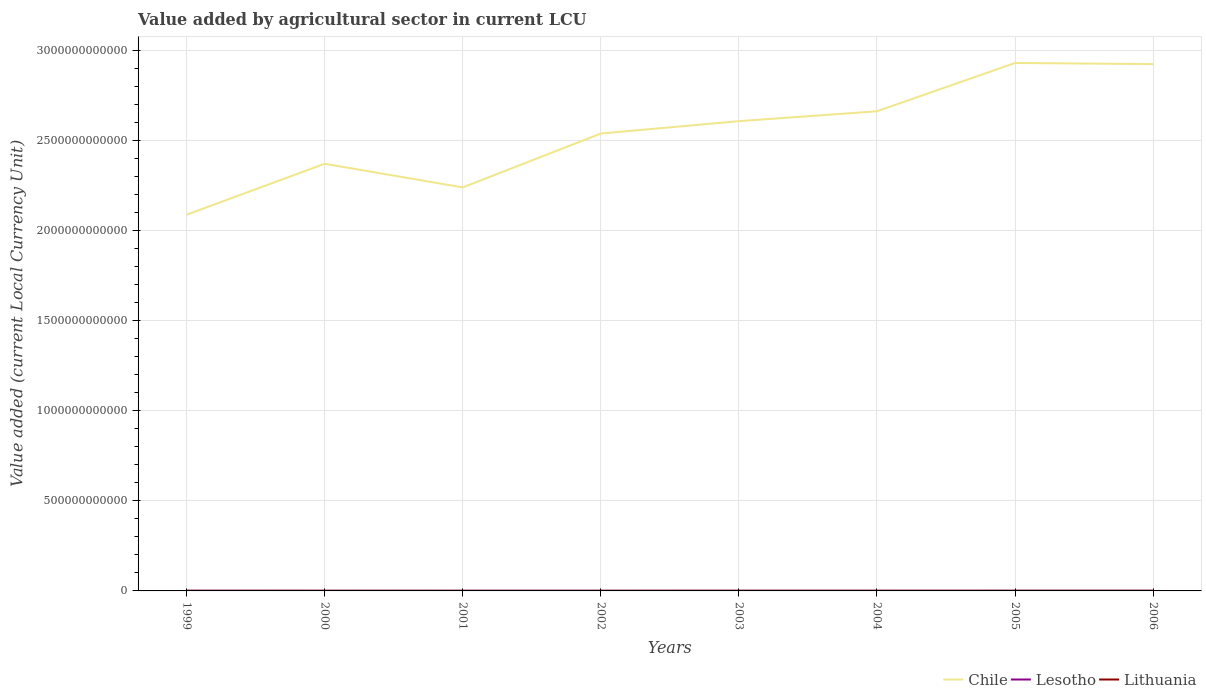Does the line corresponding to Lesotho intersect with the line corresponding to Lithuania?
Your answer should be very brief. Yes. Across all years, what is the maximum value added by agricultural sector in Lesotho?
Offer a very short reply. 5.98e+08. What is the total value added by agricultural sector in Lesotho in the graph?
Ensure brevity in your answer.  1.11e+08. What is the difference between the highest and the second highest value added by agricultural sector in Lithuania?
Provide a succinct answer. 2.38e+08. What is the difference between two consecutive major ticks on the Y-axis?
Make the answer very short. 5.00e+11. Does the graph contain any zero values?
Ensure brevity in your answer.  No. Does the graph contain grids?
Provide a succinct answer. Yes. Where does the legend appear in the graph?
Provide a short and direct response. Bottom right. How are the legend labels stacked?
Provide a short and direct response. Horizontal. What is the title of the graph?
Keep it short and to the point. Value added by agricultural sector in current LCU. What is the label or title of the X-axis?
Make the answer very short. Years. What is the label or title of the Y-axis?
Keep it short and to the point. Value added (current Local Currency Unit). What is the Value added (current Local Currency Unit) in Chile in 1999?
Your answer should be compact. 2.09e+12. What is the Value added (current Local Currency Unit) in Lesotho in 1999?
Your answer should be very brief. 8.32e+08. What is the Value added (current Local Currency Unit) in Lithuania in 1999?
Your response must be concise. 8.11e+08. What is the Value added (current Local Currency Unit) in Chile in 2000?
Offer a terse response. 2.37e+12. What is the Value added (current Local Currency Unit) of Lesotho in 2000?
Your answer should be very brief. 5.98e+08. What is the Value added (current Local Currency Unit) in Lithuania in 2000?
Provide a short and direct response. 7.46e+08. What is the Value added (current Local Currency Unit) in Chile in 2001?
Your answer should be compact. 2.24e+12. What is the Value added (current Local Currency Unit) in Lesotho in 2001?
Give a very brief answer. 7.31e+08. What is the Value added (current Local Currency Unit) in Lithuania in 2001?
Provide a succinct answer. 6.91e+08. What is the Value added (current Local Currency Unit) in Chile in 2002?
Your answer should be compact. 2.54e+12. What is the Value added (current Local Currency Unit) in Lesotho in 2002?
Your answer should be compact. 6.50e+08. What is the Value added (current Local Currency Unit) in Lithuania in 2002?
Offer a terse response. 7.25e+08. What is the Value added (current Local Currency Unit) in Chile in 2003?
Give a very brief answer. 2.61e+12. What is the Value added (current Local Currency Unit) in Lesotho in 2003?
Your answer should be very brief. 6.71e+08. What is the Value added (current Local Currency Unit) in Lithuania in 2003?
Give a very brief answer. 7.36e+08. What is the Value added (current Local Currency Unit) of Chile in 2004?
Offer a terse response. 2.66e+12. What is the Value added (current Local Currency Unit) in Lesotho in 2004?
Provide a short and direct response. 7.02e+08. What is the Value added (current Local Currency Unit) of Lithuania in 2004?
Provide a succinct answer. 7.60e+08. What is the Value added (current Local Currency Unit) of Chile in 2005?
Ensure brevity in your answer.  2.93e+12. What is the Value added (current Local Currency Unit) in Lesotho in 2005?
Keep it short and to the point. 7.21e+08. What is the Value added (current Local Currency Unit) of Lithuania in 2005?
Your response must be concise. 9.08e+08. What is the Value added (current Local Currency Unit) in Chile in 2006?
Make the answer very short. 2.92e+12. What is the Value added (current Local Currency Unit) of Lesotho in 2006?
Provide a succinct answer. 7.09e+08. What is the Value added (current Local Currency Unit) in Lithuania in 2006?
Your answer should be compact. 9.29e+08. Across all years, what is the maximum Value added (current Local Currency Unit) in Chile?
Keep it short and to the point. 2.93e+12. Across all years, what is the maximum Value added (current Local Currency Unit) in Lesotho?
Provide a short and direct response. 8.32e+08. Across all years, what is the maximum Value added (current Local Currency Unit) of Lithuania?
Provide a short and direct response. 9.29e+08. Across all years, what is the minimum Value added (current Local Currency Unit) in Chile?
Give a very brief answer. 2.09e+12. Across all years, what is the minimum Value added (current Local Currency Unit) of Lesotho?
Keep it short and to the point. 5.98e+08. Across all years, what is the minimum Value added (current Local Currency Unit) of Lithuania?
Your answer should be compact. 6.91e+08. What is the total Value added (current Local Currency Unit) in Chile in the graph?
Offer a very short reply. 2.04e+13. What is the total Value added (current Local Currency Unit) in Lesotho in the graph?
Make the answer very short. 5.61e+09. What is the total Value added (current Local Currency Unit) of Lithuania in the graph?
Your answer should be compact. 6.31e+09. What is the difference between the Value added (current Local Currency Unit) of Chile in 1999 and that in 2000?
Ensure brevity in your answer.  -2.83e+11. What is the difference between the Value added (current Local Currency Unit) of Lesotho in 1999 and that in 2000?
Offer a terse response. 2.34e+08. What is the difference between the Value added (current Local Currency Unit) in Lithuania in 1999 and that in 2000?
Offer a very short reply. 6.55e+07. What is the difference between the Value added (current Local Currency Unit) of Chile in 1999 and that in 2001?
Offer a terse response. -1.52e+11. What is the difference between the Value added (current Local Currency Unit) in Lesotho in 1999 and that in 2001?
Your response must be concise. 1.01e+08. What is the difference between the Value added (current Local Currency Unit) in Lithuania in 1999 and that in 2001?
Give a very brief answer. 1.20e+08. What is the difference between the Value added (current Local Currency Unit) in Chile in 1999 and that in 2002?
Your response must be concise. -4.51e+11. What is the difference between the Value added (current Local Currency Unit) in Lesotho in 1999 and that in 2002?
Make the answer very short. 1.82e+08. What is the difference between the Value added (current Local Currency Unit) in Lithuania in 1999 and that in 2002?
Ensure brevity in your answer.  8.63e+07. What is the difference between the Value added (current Local Currency Unit) of Chile in 1999 and that in 2003?
Provide a short and direct response. -5.19e+11. What is the difference between the Value added (current Local Currency Unit) of Lesotho in 1999 and that in 2003?
Provide a short and direct response. 1.61e+08. What is the difference between the Value added (current Local Currency Unit) of Lithuania in 1999 and that in 2003?
Provide a succinct answer. 7.49e+07. What is the difference between the Value added (current Local Currency Unit) in Chile in 1999 and that in 2004?
Your response must be concise. -5.74e+11. What is the difference between the Value added (current Local Currency Unit) in Lesotho in 1999 and that in 2004?
Make the answer very short. 1.30e+08. What is the difference between the Value added (current Local Currency Unit) of Lithuania in 1999 and that in 2004?
Provide a short and direct response. 5.10e+07. What is the difference between the Value added (current Local Currency Unit) in Chile in 1999 and that in 2005?
Your answer should be compact. -8.42e+11. What is the difference between the Value added (current Local Currency Unit) in Lesotho in 1999 and that in 2005?
Your answer should be compact. 1.11e+08. What is the difference between the Value added (current Local Currency Unit) in Lithuania in 1999 and that in 2005?
Ensure brevity in your answer.  -9.68e+07. What is the difference between the Value added (current Local Currency Unit) in Chile in 1999 and that in 2006?
Offer a terse response. -8.36e+11. What is the difference between the Value added (current Local Currency Unit) in Lesotho in 1999 and that in 2006?
Offer a terse response. 1.23e+08. What is the difference between the Value added (current Local Currency Unit) in Lithuania in 1999 and that in 2006?
Your answer should be very brief. -1.18e+08. What is the difference between the Value added (current Local Currency Unit) of Chile in 2000 and that in 2001?
Your answer should be compact. 1.31e+11. What is the difference between the Value added (current Local Currency Unit) of Lesotho in 2000 and that in 2001?
Ensure brevity in your answer.  -1.33e+08. What is the difference between the Value added (current Local Currency Unit) in Lithuania in 2000 and that in 2001?
Give a very brief answer. 5.48e+07. What is the difference between the Value added (current Local Currency Unit) in Chile in 2000 and that in 2002?
Keep it short and to the point. -1.68e+11. What is the difference between the Value added (current Local Currency Unit) in Lesotho in 2000 and that in 2002?
Your answer should be very brief. -5.16e+07. What is the difference between the Value added (current Local Currency Unit) in Lithuania in 2000 and that in 2002?
Ensure brevity in your answer.  2.08e+07. What is the difference between the Value added (current Local Currency Unit) of Chile in 2000 and that in 2003?
Your answer should be compact. -2.36e+11. What is the difference between the Value added (current Local Currency Unit) of Lesotho in 2000 and that in 2003?
Provide a short and direct response. -7.26e+07. What is the difference between the Value added (current Local Currency Unit) of Lithuania in 2000 and that in 2003?
Provide a succinct answer. 9.41e+06. What is the difference between the Value added (current Local Currency Unit) of Chile in 2000 and that in 2004?
Keep it short and to the point. -2.91e+11. What is the difference between the Value added (current Local Currency Unit) in Lesotho in 2000 and that in 2004?
Your response must be concise. -1.04e+08. What is the difference between the Value added (current Local Currency Unit) in Lithuania in 2000 and that in 2004?
Offer a very short reply. -1.45e+07. What is the difference between the Value added (current Local Currency Unit) of Chile in 2000 and that in 2005?
Provide a short and direct response. -5.59e+11. What is the difference between the Value added (current Local Currency Unit) in Lesotho in 2000 and that in 2005?
Offer a terse response. -1.23e+08. What is the difference between the Value added (current Local Currency Unit) of Lithuania in 2000 and that in 2005?
Provide a succinct answer. -1.62e+08. What is the difference between the Value added (current Local Currency Unit) in Chile in 2000 and that in 2006?
Ensure brevity in your answer.  -5.53e+11. What is the difference between the Value added (current Local Currency Unit) in Lesotho in 2000 and that in 2006?
Your response must be concise. -1.10e+08. What is the difference between the Value added (current Local Currency Unit) in Lithuania in 2000 and that in 2006?
Offer a terse response. -1.84e+08. What is the difference between the Value added (current Local Currency Unit) in Chile in 2001 and that in 2002?
Your answer should be compact. -2.99e+11. What is the difference between the Value added (current Local Currency Unit) of Lesotho in 2001 and that in 2002?
Your response must be concise. 8.10e+07. What is the difference between the Value added (current Local Currency Unit) in Lithuania in 2001 and that in 2002?
Provide a succinct answer. -3.39e+07. What is the difference between the Value added (current Local Currency Unit) of Chile in 2001 and that in 2003?
Offer a terse response. -3.68e+11. What is the difference between the Value added (current Local Currency Unit) of Lesotho in 2001 and that in 2003?
Your answer should be compact. 6.00e+07. What is the difference between the Value added (current Local Currency Unit) of Lithuania in 2001 and that in 2003?
Ensure brevity in your answer.  -4.54e+07. What is the difference between the Value added (current Local Currency Unit) in Chile in 2001 and that in 2004?
Keep it short and to the point. -4.23e+11. What is the difference between the Value added (current Local Currency Unit) in Lesotho in 2001 and that in 2004?
Provide a succinct answer. 2.90e+07. What is the difference between the Value added (current Local Currency Unit) of Lithuania in 2001 and that in 2004?
Ensure brevity in your answer.  -6.93e+07. What is the difference between the Value added (current Local Currency Unit) of Chile in 2001 and that in 2005?
Ensure brevity in your answer.  -6.91e+11. What is the difference between the Value added (current Local Currency Unit) of Lesotho in 2001 and that in 2005?
Ensure brevity in your answer.  9.99e+06. What is the difference between the Value added (current Local Currency Unit) of Lithuania in 2001 and that in 2005?
Your response must be concise. -2.17e+08. What is the difference between the Value added (current Local Currency Unit) in Chile in 2001 and that in 2006?
Offer a very short reply. -6.85e+11. What is the difference between the Value added (current Local Currency Unit) of Lesotho in 2001 and that in 2006?
Offer a terse response. 2.23e+07. What is the difference between the Value added (current Local Currency Unit) of Lithuania in 2001 and that in 2006?
Your answer should be compact. -2.38e+08. What is the difference between the Value added (current Local Currency Unit) of Chile in 2002 and that in 2003?
Offer a very short reply. -6.88e+1. What is the difference between the Value added (current Local Currency Unit) of Lesotho in 2002 and that in 2003?
Offer a very short reply. -2.10e+07. What is the difference between the Value added (current Local Currency Unit) in Lithuania in 2002 and that in 2003?
Offer a very short reply. -1.14e+07. What is the difference between the Value added (current Local Currency Unit) in Chile in 2002 and that in 2004?
Ensure brevity in your answer.  -1.24e+11. What is the difference between the Value added (current Local Currency Unit) in Lesotho in 2002 and that in 2004?
Offer a terse response. -5.20e+07. What is the difference between the Value added (current Local Currency Unit) of Lithuania in 2002 and that in 2004?
Your answer should be very brief. -3.53e+07. What is the difference between the Value added (current Local Currency Unit) in Chile in 2002 and that in 2005?
Keep it short and to the point. -3.92e+11. What is the difference between the Value added (current Local Currency Unit) in Lesotho in 2002 and that in 2005?
Provide a short and direct response. -7.10e+07. What is the difference between the Value added (current Local Currency Unit) in Lithuania in 2002 and that in 2005?
Make the answer very short. -1.83e+08. What is the difference between the Value added (current Local Currency Unit) of Chile in 2002 and that in 2006?
Offer a very short reply. -3.86e+11. What is the difference between the Value added (current Local Currency Unit) of Lesotho in 2002 and that in 2006?
Offer a terse response. -5.87e+07. What is the difference between the Value added (current Local Currency Unit) in Lithuania in 2002 and that in 2006?
Ensure brevity in your answer.  -2.04e+08. What is the difference between the Value added (current Local Currency Unit) in Chile in 2003 and that in 2004?
Your response must be concise. -5.49e+1. What is the difference between the Value added (current Local Currency Unit) of Lesotho in 2003 and that in 2004?
Provide a succinct answer. -3.10e+07. What is the difference between the Value added (current Local Currency Unit) in Lithuania in 2003 and that in 2004?
Provide a succinct answer. -2.39e+07. What is the difference between the Value added (current Local Currency Unit) in Chile in 2003 and that in 2005?
Give a very brief answer. -3.23e+11. What is the difference between the Value added (current Local Currency Unit) in Lesotho in 2003 and that in 2005?
Offer a very short reply. -5.00e+07. What is the difference between the Value added (current Local Currency Unit) of Lithuania in 2003 and that in 2005?
Your answer should be compact. -1.72e+08. What is the difference between the Value added (current Local Currency Unit) in Chile in 2003 and that in 2006?
Make the answer very short. -3.17e+11. What is the difference between the Value added (current Local Currency Unit) in Lesotho in 2003 and that in 2006?
Offer a very short reply. -3.77e+07. What is the difference between the Value added (current Local Currency Unit) in Lithuania in 2003 and that in 2006?
Offer a terse response. -1.93e+08. What is the difference between the Value added (current Local Currency Unit) in Chile in 2004 and that in 2005?
Ensure brevity in your answer.  -2.68e+11. What is the difference between the Value added (current Local Currency Unit) in Lesotho in 2004 and that in 2005?
Offer a terse response. -1.90e+07. What is the difference between the Value added (current Local Currency Unit) of Lithuania in 2004 and that in 2005?
Provide a succinct answer. -1.48e+08. What is the difference between the Value added (current Local Currency Unit) of Chile in 2004 and that in 2006?
Your answer should be compact. -2.62e+11. What is the difference between the Value added (current Local Currency Unit) in Lesotho in 2004 and that in 2006?
Provide a short and direct response. -6.68e+06. What is the difference between the Value added (current Local Currency Unit) of Lithuania in 2004 and that in 2006?
Your answer should be very brief. -1.69e+08. What is the difference between the Value added (current Local Currency Unit) in Chile in 2005 and that in 2006?
Your response must be concise. 6.26e+09. What is the difference between the Value added (current Local Currency Unit) of Lesotho in 2005 and that in 2006?
Your answer should be compact. 1.23e+07. What is the difference between the Value added (current Local Currency Unit) of Lithuania in 2005 and that in 2006?
Ensure brevity in your answer.  -2.14e+07. What is the difference between the Value added (current Local Currency Unit) in Chile in 1999 and the Value added (current Local Currency Unit) in Lesotho in 2000?
Provide a succinct answer. 2.09e+12. What is the difference between the Value added (current Local Currency Unit) of Chile in 1999 and the Value added (current Local Currency Unit) of Lithuania in 2000?
Give a very brief answer. 2.09e+12. What is the difference between the Value added (current Local Currency Unit) of Lesotho in 1999 and the Value added (current Local Currency Unit) of Lithuania in 2000?
Give a very brief answer. 8.61e+07. What is the difference between the Value added (current Local Currency Unit) of Chile in 1999 and the Value added (current Local Currency Unit) of Lesotho in 2001?
Offer a very short reply. 2.09e+12. What is the difference between the Value added (current Local Currency Unit) of Chile in 1999 and the Value added (current Local Currency Unit) of Lithuania in 2001?
Offer a terse response. 2.09e+12. What is the difference between the Value added (current Local Currency Unit) in Lesotho in 1999 and the Value added (current Local Currency Unit) in Lithuania in 2001?
Ensure brevity in your answer.  1.41e+08. What is the difference between the Value added (current Local Currency Unit) of Chile in 1999 and the Value added (current Local Currency Unit) of Lesotho in 2002?
Offer a terse response. 2.09e+12. What is the difference between the Value added (current Local Currency Unit) of Chile in 1999 and the Value added (current Local Currency Unit) of Lithuania in 2002?
Offer a terse response. 2.09e+12. What is the difference between the Value added (current Local Currency Unit) of Lesotho in 1999 and the Value added (current Local Currency Unit) of Lithuania in 2002?
Provide a short and direct response. 1.07e+08. What is the difference between the Value added (current Local Currency Unit) in Chile in 1999 and the Value added (current Local Currency Unit) in Lesotho in 2003?
Your response must be concise. 2.09e+12. What is the difference between the Value added (current Local Currency Unit) of Chile in 1999 and the Value added (current Local Currency Unit) of Lithuania in 2003?
Make the answer very short. 2.09e+12. What is the difference between the Value added (current Local Currency Unit) in Lesotho in 1999 and the Value added (current Local Currency Unit) in Lithuania in 2003?
Offer a terse response. 9.55e+07. What is the difference between the Value added (current Local Currency Unit) of Chile in 1999 and the Value added (current Local Currency Unit) of Lesotho in 2004?
Your answer should be compact. 2.09e+12. What is the difference between the Value added (current Local Currency Unit) in Chile in 1999 and the Value added (current Local Currency Unit) in Lithuania in 2004?
Offer a terse response. 2.09e+12. What is the difference between the Value added (current Local Currency Unit) in Lesotho in 1999 and the Value added (current Local Currency Unit) in Lithuania in 2004?
Your answer should be very brief. 7.16e+07. What is the difference between the Value added (current Local Currency Unit) in Chile in 1999 and the Value added (current Local Currency Unit) in Lesotho in 2005?
Make the answer very short. 2.09e+12. What is the difference between the Value added (current Local Currency Unit) of Chile in 1999 and the Value added (current Local Currency Unit) of Lithuania in 2005?
Make the answer very short. 2.09e+12. What is the difference between the Value added (current Local Currency Unit) in Lesotho in 1999 and the Value added (current Local Currency Unit) in Lithuania in 2005?
Provide a succinct answer. -7.62e+07. What is the difference between the Value added (current Local Currency Unit) in Chile in 1999 and the Value added (current Local Currency Unit) in Lesotho in 2006?
Your answer should be compact. 2.09e+12. What is the difference between the Value added (current Local Currency Unit) in Chile in 1999 and the Value added (current Local Currency Unit) in Lithuania in 2006?
Make the answer very short. 2.09e+12. What is the difference between the Value added (current Local Currency Unit) in Lesotho in 1999 and the Value added (current Local Currency Unit) in Lithuania in 2006?
Ensure brevity in your answer.  -9.76e+07. What is the difference between the Value added (current Local Currency Unit) of Chile in 2000 and the Value added (current Local Currency Unit) of Lesotho in 2001?
Make the answer very short. 2.37e+12. What is the difference between the Value added (current Local Currency Unit) of Chile in 2000 and the Value added (current Local Currency Unit) of Lithuania in 2001?
Provide a short and direct response. 2.37e+12. What is the difference between the Value added (current Local Currency Unit) of Lesotho in 2000 and the Value added (current Local Currency Unit) of Lithuania in 2001?
Your answer should be compact. -9.26e+07. What is the difference between the Value added (current Local Currency Unit) in Chile in 2000 and the Value added (current Local Currency Unit) in Lesotho in 2002?
Keep it short and to the point. 2.37e+12. What is the difference between the Value added (current Local Currency Unit) in Chile in 2000 and the Value added (current Local Currency Unit) in Lithuania in 2002?
Keep it short and to the point. 2.37e+12. What is the difference between the Value added (current Local Currency Unit) of Lesotho in 2000 and the Value added (current Local Currency Unit) of Lithuania in 2002?
Offer a terse response. -1.27e+08. What is the difference between the Value added (current Local Currency Unit) of Chile in 2000 and the Value added (current Local Currency Unit) of Lesotho in 2003?
Keep it short and to the point. 2.37e+12. What is the difference between the Value added (current Local Currency Unit) in Chile in 2000 and the Value added (current Local Currency Unit) in Lithuania in 2003?
Make the answer very short. 2.37e+12. What is the difference between the Value added (current Local Currency Unit) in Lesotho in 2000 and the Value added (current Local Currency Unit) in Lithuania in 2003?
Offer a very short reply. -1.38e+08. What is the difference between the Value added (current Local Currency Unit) in Chile in 2000 and the Value added (current Local Currency Unit) in Lesotho in 2004?
Provide a succinct answer. 2.37e+12. What is the difference between the Value added (current Local Currency Unit) in Chile in 2000 and the Value added (current Local Currency Unit) in Lithuania in 2004?
Give a very brief answer. 2.37e+12. What is the difference between the Value added (current Local Currency Unit) of Lesotho in 2000 and the Value added (current Local Currency Unit) of Lithuania in 2004?
Your answer should be compact. -1.62e+08. What is the difference between the Value added (current Local Currency Unit) of Chile in 2000 and the Value added (current Local Currency Unit) of Lesotho in 2005?
Provide a succinct answer. 2.37e+12. What is the difference between the Value added (current Local Currency Unit) in Chile in 2000 and the Value added (current Local Currency Unit) in Lithuania in 2005?
Ensure brevity in your answer.  2.37e+12. What is the difference between the Value added (current Local Currency Unit) of Lesotho in 2000 and the Value added (current Local Currency Unit) of Lithuania in 2005?
Offer a very short reply. -3.10e+08. What is the difference between the Value added (current Local Currency Unit) in Chile in 2000 and the Value added (current Local Currency Unit) in Lesotho in 2006?
Give a very brief answer. 2.37e+12. What is the difference between the Value added (current Local Currency Unit) of Chile in 2000 and the Value added (current Local Currency Unit) of Lithuania in 2006?
Offer a very short reply. 2.37e+12. What is the difference between the Value added (current Local Currency Unit) of Lesotho in 2000 and the Value added (current Local Currency Unit) of Lithuania in 2006?
Ensure brevity in your answer.  -3.31e+08. What is the difference between the Value added (current Local Currency Unit) of Chile in 2001 and the Value added (current Local Currency Unit) of Lesotho in 2002?
Offer a terse response. 2.24e+12. What is the difference between the Value added (current Local Currency Unit) in Chile in 2001 and the Value added (current Local Currency Unit) in Lithuania in 2002?
Your response must be concise. 2.24e+12. What is the difference between the Value added (current Local Currency Unit) of Lesotho in 2001 and the Value added (current Local Currency Unit) of Lithuania in 2002?
Ensure brevity in your answer.  6.02e+06. What is the difference between the Value added (current Local Currency Unit) of Chile in 2001 and the Value added (current Local Currency Unit) of Lesotho in 2003?
Ensure brevity in your answer.  2.24e+12. What is the difference between the Value added (current Local Currency Unit) in Chile in 2001 and the Value added (current Local Currency Unit) in Lithuania in 2003?
Your response must be concise. 2.24e+12. What is the difference between the Value added (current Local Currency Unit) in Lesotho in 2001 and the Value added (current Local Currency Unit) in Lithuania in 2003?
Offer a terse response. -5.41e+06. What is the difference between the Value added (current Local Currency Unit) in Chile in 2001 and the Value added (current Local Currency Unit) in Lesotho in 2004?
Your answer should be very brief. 2.24e+12. What is the difference between the Value added (current Local Currency Unit) of Chile in 2001 and the Value added (current Local Currency Unit) of Lithuania in 2004?
Keep it short and to the point. 2.24e+12. What is the difference between the Value added (current Local Currency Unit) in Lesotho in 2001 and the Value added (current Local Currency Unit) in Lithuania in 2004?
Provide a succinct answer. -2.93e+07. What is the difference between the Value added (current Local Currency Unit) in Chile in 2001 and the Value added (current Local Currency Unit) in Lesotho in 2005?
Your answer should be very brief. 2.24e+12. What is the difference between the Value added (current Local Currency Unit) in Chile in 2001 and the Value added (current Local Currency Unit) in Lithuania in 2005?
Make the answer very short. 2.24e+12. What is the difference between the Value added (current Local Currency Unit) in Lesotho in 2001 and the Value added (current Local Currency Unit) in Lithuania in 2005?
Offer a terse response. -1.77e+08. What is the difference between the Value added (current Local Currency Unit) in Chile in 2001 and the Value added (current Local Currency Unit) in Lesotho in 2006?
Make the answer very short. 2.24e+12. What is the difference between the Value added (current Local Currency Unit) of Chile in 2001 and the Value added (current Local Currency Unit) of Lithuania in 2006?
Your response must be concise. 2.24e+12. What is the difference between the Value added (current Local Currency Unit) in Lesotho in 2001 and the Value added (current Local Currency Unit) in Lithuania in 2006?
Your answer should be compact. -1.98e+08. What is the difference between the Value added (current Local Currency Unit) in Chile in 2002 and the Value added (current Local Currency Unit) in Lesotho in 2003?
Ensure brevity in your answer.  2.54e+12. What is the difference between the Value added (current Local Currency Unit) in Chile in 2002 and the Value added (current Local Currency Unit) in Lithuania in 2003?
Provide a short and direct response. 2.54e+12. What is the difference between the Value added (current Local Currency Unit) of Lesotho in 2002 and the Value added (current Local Currency Unit) of Lithuania in 2003?
Make the answer very short. -8.64e+07. What is the difference between the Value added (current Local Currency Unit) of Chile in 2002 and the Value added (current Local Currency Unit) of Lesotho in 2004?
Your response must be concise. 2.54e+12. What is the difference between the Value added (current Local Currency Unit) of Chile in 2002 and the Value added (current Local Currency Unit) of Lithuania in 2004?
Your response must be concise. 2.54e+12. What is the difference between the Value added (current Local Currency Unit) of Lesotho in 2002 and the Value added (current Local Currency Unit) of Lithuania in 2004?
Keep it short and to the point. -1.10e+08. What is the difference between the Value added (current Local Currency Unit) of Chile in 2002 and the Value added (current Local Currency Unit) of Lesotho in 2005?
Provide a succinct answer. 2.54e+12. What is the difference between the Value added (current Local Currency Unit) of Chile in 2002 and the Value added (current Local Currency Unit) of Lithuania in 2005?
Make the answer very short. 2.54e+12. What is the difference between the Value added (current Local Currency Unit) in Lesotho in 2002 and the Value added (current Local Currency Unit) in Lithuania in 2005?
Ensure brevity in your answer.  -2.58e+08. What is the difference between the Value added (current Local Currency Unit) of Chile in 2002 and the Value added (current Local Currency Unit) of Lesotho in 2006?
Your response must be concise. 2.54e+12. What is the difference between the Value added (current Local Currency Unit) of Chile in 2002 and the Value added (current Local Currency Unit) of Lithuania in 2006?
Your answer should be compact. 2.54e+12. What is the difference between the Value added (current Local Currency Unit) of Lesotho in 2002 and the Value added (current Local Currency Unit) of Lithuania in 2006?
Ensure brevity in your answer.  -2.79e+08. What is the difference between the Value added (current Local Currency Unit) of Chile in 2003 and the Value added (current Local Currency Unit) of Lesotho in 2004?
Offer a terse response. 2.61e+12. What is the difference between the Value added (current Local Currency Unit) of Chile in 2003 and the Value added (current Local Currency Unit) of Lithuania in 2004?
Offer a terse response. 2.61e+12. What is the difference between the Value added (current Local Currency Unit) of Lesotho in 2003 and the Value added (current Local Currency Unit) of Lithuania in 2004?
Provide a short and direct response. -8.93e+07. What is the difference between the Value added (current Local Currency Unit) of Chile in 2003 and the Value added (current Local Currency Unit) of Lesotho in 2005?
Make the answer very short. 2.61e+12. What is the difference between the Value added (current Local Currency Unit) of Chile in 2003 and the Value added (current Local Currency Unit) of Lithuania in 2005?
Make the answer very short. 2.61e+12. What is the difference between the Value added (current Local Currency Unit) of Lesotho in 2003 and the Value added (current Local Currency Unit) of Lithuania in 2005?
Keep it short and to the point. -2.37e+08. What is the difference between the Value added (current Local Currency Unit) of Chile in 2003 and the Value added (current Local Currency Unit) of Lesotho in 2006?
Offer a very short reply. 2.61e+12. What is the difference between the Value added (current Local Currency Unit) in Chile in 2003 and the Value added (current Local Currency Unit) in Lithuania in 2006?
Your answer should be very brief. 2.61e+12. What is the difference between the Value added (current Local Currency Unit) of Lesotho in 2003 and the Value added (current Local Currency Unit) of Lithuania in 2006?
Ensure brevity in your answer.  -2.58e+08. What is the difference between the Value added (current Local Currency Unit) in Chile in 2004 and the Value added (current Local Currency Unit) in Lesotho in 2005?
Ensure brevity in your answer.  2.66e+12. What is the difference between the Value added (current Local Currency Unit) of Chile in 2004 and the Value added (current Local Currency Unit) of Lithuania in 2005?
Keep it short and to the point. 2.66e+12. What is the difference between the Value added (current Local Currency Unit) of Lesotho in 2004 and the Value added (current Local Currency Unit) of Lithuania in 2005?
Your response must be concise. -2.06e+08. What is the difference between the Value added (current Local Currency Unit) in Chile in 2004 and the Value added (current Local Currency Unit) in Lesotho in 2006?
Offer a very short reply. 2.66e+12. What is the difference between the Value added (current Local Currency Unit) of Chile in 2004 and the Value added (current Local Currency Unit) of Lithuania in 2006?
Offer a very short reply. 2.66e+12. What is the difference between the Value added (current Local Currency Unit) of Lesotho in 2004 and the Value added (current Local Currency Unit) of Lithuania in 2006?
Give a very brief answer. -2.27e+08. What is the difference between the Value added (current Local Currency Unit) in Chile in 2005 and the Value added (current Local Currency Unit) in Lesotho in 2006?
Offer a very short reply. 2.93e+12. What is the difference between the Value added (current Local Currency Unit) in Chile in 2005 and the Value added (current Local Currency Unit) in Lithuania in 2006?
Your answer should be very brief. 2.93e+12. What is the difference between the Value added (current Local Currency Unit) in Lesotho in 2005 and the Value added (current Local Currency Unit) in Lithuania in 2006?
Your response must be concise. -2.08e+08. What is the average Value added (current Local Currency Unit) in Chile per year?
Provide a short and direct response. 2.55e+12. What is the average Value added (current Local Currency Unit) in Lesotho per year?
Provide a succinct answer. 7.02e+08. What is the average Value added (current Local Currency Unit) of Lithuania per year?
Offer a very short reply. 7.88e+08. In the year 1999, what is the difference between the Value added (current Local Currency Unit) in Chile and Value added (current Local Currency Unit) in Lesotho?
Offer a very short reply. 2.09e+12. In the year 1999, what is the difference between the Value added (current Local Currency Unit) of Chile and Value added (current Local Currency Unit) of Lithuania?
Your answer should be compact. 2.09e+12. In the year 1999, what is the difference between the Value added (current Local Currency Unit) in Lesotho and Value added (current Local Currency Unit) in Lithuania?
Give a very brief answer. 2.06e+07. In the year 2000, what is the difference between the Value added (current Local Currency Unit) of Chile and Value added (current Local Currency Unit) of Lesotho?
Your response must be concise. 2.37e+12. In the year 2000, what is the difference between the Value added (current Local Currency Unit) in Chile and Value added (current Local Currency Unit) in Lithuania?
Give a very brief answer. 2.37e+12. In the year 2000, what is the difference between the Value added (current Local Currency Unit) in Lesotho and Value added (current Local Currency Unit) in Lithuania?
Give a very brief answer. -1.47e+08. In the year 2001, what is the difference between the Value added (current Local Currency Unit) in Chile and Value added (current Local Currency Unit) in Lesotho?
Provide a succinct answer. 2.24e+12. In the year 2001, what is the difference between the Value added (current Local Currency Unit) of Chile and Value added (current Local Currency Unit) of Lithuania?
Your answer should be compact. 2.24e+12. In the year 2001, what is the difference between the Value added (current Local Currency Unit) of Lesotho and Value added (current Local Currency Unit) of Lithuania?
Offer a terse response. 4.00e+07. In the year 2002, what is the difference between the Value added (current Local Currency Unit) of Chile and Value added (current Local Currency Unit) of Lesotho?
Ensure brevity in your answer.  2.54e+12. In the year 2002, what is the difference between the Value added (current Local Currency Unit) of Chile and Value added (current Local Currency Unit) of Lithuania?
Give a very brief answer. 2.54e+12. In the year 2002, what is the difference between the Value added (current Local Currency Unit) of Lesotho and Value added (current Local Currency Unit) of Lithuania?
Make the answer very short. -7.50e+07. In the year 2003, what is the difference between the Value added (current Local Currency Unit) in Chile and Value added (current Local Currency Unit) in Lesotho?
Offer a terse response. 2.61e+12. In the year 2003, what is the difference between the Value added (current Local Currency Unit) of Chile and Value added (current Local Currency Unit) of Lithuania?
Provide a succinct answer. 2.61e+12. In the year 2003, what is the difference between the Value added (current Local Currency Unit) of Lesotho and Value added (current Local Currency Unit) of Lithuania?
Provide a succinct answer. -6.54e+07. In the year 2004, what is the difference between the Value added (current Local Currency Unit) in Chile and Value added (current Local Currency Unit) in Lesotho?
Offer a very short reply. 2.66e+12. In the year 2004, what is the difference between the Value added (current Local Currency Unit) in Chile and Value added (current Local Currency Unit) in Lithuania?
Make the answer very short. 2.66e+12. In the year 2004, what is the difference between the Value added (current Local Currency Unit) of Lesotho and Value added (current Local Currency Unit) of Lithuania?
Your answer should be compact. -5.83e+07. In the year 2005, what is the difference between the Value added (current Local Currency Unit) of Chile and Value added (current Local Currency Unit) of Lesotho?
Give a very brief answer. 2.93e+12. In the year 2005, what is the difference between the Value added (current Local Currency Unit) in Chile and Value added (current Local Currency Unit) in Lithuania?
Your answer should be compact. 2.93e+12. In the year 2005, what is the difference between the Value added (current Local Currency Unit) in Lesotho and Value added (current Local Currency Unit) in Lithuania?
Give a very brief answer. -1.87e+08. In the year 2006, what is the difference between the Value added (current Local Currency Unit) in Chile and Value added (current Local Currency Unit) in Lesotho?
Your answer should be very brief. 2.92e+12. In the year 2006, what is the difference between the Value added (current Local Currency Unit) of Chile and Value added (current Local Currency Unit) of Lithuania?
Keep it short and to the point. 2.92e+12. In the year 2006, what is the difference between the Value added (current Local Currency Unit) in Lesotho and Value added (current Local Currency Unit) in Lithuania?
Ensure brevity in your answer.  -2.21e+08. What is the ratio of the Value added (current Local Currency Unit) of Chile in 1999 to that in 2000?
Provide a succinct answer. 0.88. What is the ratio of the Value added (current Local Currency Unit) of Lesotho in 1999 to that in 2000?
Offer a very short reply. 1.39. What is the ratio of the Value added (current Local Currency Unit) in Lithuania in 1999 to that in 2000?
Your answer should be compact. 1.09. What is the ratio of the Value added (current Local Currency Unit) of Chile in 1999 to that in 2001?
Offer a terse response. 0.93. What is the ratio of the Value added (current Local Currency Unit) of Lesotho in 1999 to that in 2001?
Ensure brevity in your answer.  1.14. What is the ratio of the Value added (current Local Currency Unit) of Lithuania in 1999 to that in 2001?
Keep it short and to the point. 1.17. What is the ratio of the Value added (current Local Currency Unit) in Chile in 1999 to that in 2002?
Ensure brevity in your answer.  0.82. What is the ratio of the Value added (current Local Currency Unit) in Lesotho in 1999 to that in 2002?
Offer a very short reply. 1.28. What is the ratio of the Value added (current Local Currency Unit) in Lithuania in 1999 to that in 2002?
Offer a terse response. 1.12. What is the ratio of the Value added (current Local Currency Unit) of Chile in 1999 to that in 2003?
Give a very brief answer. 0.8. What is the ratio of the Value added (current Local Currency Unit) in Lesotho in 1999 to that in 2003?
Your answer should be very brief. 1.24. What is the ratio of the Value added (current Local Currency Unit) in Lithuania in 1999 to that in 2003?
Provide a succinct answer. 1.1. What is the ratio of the Value added (current Local Currency Unit) of Chile in 1999 to that in 2004?
Provide a succinct answer. 0.78. What is the ratio of the Value added (current Local Currency Unit) in Lesotho in 1999 to that in 2004?
Provide a short and direct response. 1.19. What is the ratio of the Value added (current Local Currency Unit) in Lithuania in 1999 to that in 2004?
Ensure brevity in your answer.  1.07. What is the ratio of the Value added (current Local Currency Unit) of Chile in 1999 to that in 2005?
Provide a short and direct response. 0.71. What is the ratio of the Value added (current Local Currency Unit) in Lesotho in 1999 to that in 2005?
Give a very brief answer. 1.15. What is the ratio of the Value added (current Local Currency Unit) of Lithuania in 1999 to that in 2005?
Provide a succinct answer. 0.89. What is the ratio of the Value added (current Local Currency Unit) of Chile in 1999 to that in 2006?
Offer a very short reply. 0.71. What is the ratio of the Value added (current Local Currency Unit) in Lesotho in 1999 to that in 2006?
Offer a terse response. 1.17. What is the ratio of the Value added (current Local Currency Unit) in Lithuania in 1999 to that in 2006?
Keep it short and to the point. 0.87. What is the ratio of the Value added (current Local Currency Unit) of Chile in 2000 to that in 2001?
Your response must be concise. 1.06. What is the ratio of the Value added (current Local Currency Unit) of Lesotho in 2000 to that in 2001?
Ensure brevity in your answer.  0.82. What is the ratio of the Value added (current Local Currency Unit) in Lithuania in 2000 to that in 2001?
Offer a very short reply. 1.08. What is the ratio of the Value added (current Local Currency Unit) of Chile in 2000 to that in 2002?
Keep it short and to the point. 0.93. What is the ratio of the Value added (current Local Currency Unit) of Lesotho in 2000 to that in 2002?
Your answer should be compact. 0.92. What is the ratio of the Value added (current Local Currency Unit) in Lithuania in 2000 to that in 2002?
Ensure brevity in your answer.  1.03. What is the ratio of the Value added (current Local Currency Unit) in Chile in 2000 to that in 2003?
Your answer should be very brief. 0.91. What is the ratio of the Value added (current Local Currency Unit) in Lesotho in 2000 to that in 2003?
Provide a short and direct response. 0.89. What is the ratio of the Value added (current Local Currency Unit) of Lithuania in 2000 to that in 2003?
Offer a terse response. 1.01. What is the ratio of the Value added (current Local Currency Unit) of Chile in 2000 to that in 2004?
Keep it short and to the point. 0.89. What is the ratio of the Value added (current Local Currency Unit) of Lesotho in 2000 to that in 2004?
Keep it short and to the point. 0.85. What is the ratio of the Value added (current Local Currency Unit) of Chile in 2000 to that in 2005?
Provide a succinct answer. 0.81. What is the ratio of the Value added (current Local Currency Unit) in Lesotho in 2000 to that in 2005?
Offer a very short reply. 0.83. What is the ratio of the Value added (current Local Currency Unit) of Lithuania in 2000 to that in 2005?
Your response must be concise. 0.82. What is the ratio of the Value added (current Local Currency Unit) of Chile in 2000 to that in 2006?
Your response must be concise. 0.81. What is the ratio of the Value added (current Local Currency Unit) in Lesotho in 2000 to that in 2006?
Offer a terse response. 0.84. What is the ratio of the Value added (current Local Currency Unit) in Lithuania in 2000 to that in 2006?
Make the answer very short. 0.8. What is the ratio of the Value added (current Local Currency Unit) in Chile in 2001 to that in 2002?
Your answer should be compact. 0.88. What is the ratio of the Value added (current Local Currency Unit) of Lesotho in 2001 to that in 2002?
Make the answer very short. 1.12. What is the ratio of the Value added (current Local Currency Unit) of Lithuania in 2001 to that in 2002?
Give a very brief answer. 0.95. What is the ratio of the Value added (current Local Currency Unit) in Chile in 2001 to that in 2003?
Keep it short and to the point. 0.86. What is the ratio of the Value added (current Local Currency Unit) in Lesotho in 2001 to that in 2003?
Provide a succinct answer. 1.09. What is the ratio of the Value added (current Local Currency Unit) of Lithuania in 2001 to that in 2003?
Provide a succinct answer. 0.94. What is the ratio of the Value added (current Local Currency Unit) of Chile in 2001 to that in 2004?
Provide a succinct answer. 0.84. What is the ratio of the Value added (current Local Currency Unit) in Lesotho in 2001 to that in 2004?
Make the answer very short. 1.04. What is the ratio of the Value added (current Local Currency Unit) of Lithuania in 2001 to that in 2004?
Give a very brief answer. 0.91. What is the ratio of the Value added (current Local Currency Unit) in Chile in 2001 to that in 2005?
Provide a short and direct response. 0.76. What is the ratio of the Value added (current Local Currency Unit) in Lesotho in 2001 to that in 2005?
Make the answer very short. 1.01. What is the ratio of the Value added (current Local Currency Unit) in Lithuania in 2001 to that in 2005?
Give a very brief answer. 0.76. What is the ratio of the Value added (current Local Currency Unit) of Chile in 2001 to that in 2006?
Your response must be concise. 0.77. What is the ratio of the Value added (current Local Currency Unit) in Lesotho in 2001 to that in 2006?
Offer a terse response. 1.03. What is the ratio of the Value added (current Local Currency Unit) in Lithuania in 2001 to that in 2006?
Your response must be concise. 0.74. What is the ratio of the Value added (current Local Currency Unit) of Chile in 2002 to that in 2003?
Provide a short and direct response. 0.97. What is the ratio of the Value added (current Local Currency Unit) in Lesotho in 2002 to that in 2003?
Give a very brief answer. 0.97. What is the ratio of the Value added (current Local Currency Unit) in Lithuania in 2002 to that in 2003?
Keep it short and to the point. 0.98. What is the ratio of the Value added (current Local Currency Unit) of Chile in 2002 to that in 2004?
Your answer should be very brief. 0.95. What is the ratio of the Value added (current Local Currency Unit) in Lesotho in 2002 to that in 2004?
Your answer should be compact. 0.93. What is the ratio of the Value added (current Local Currency Unit) of Lithuania in 2002 to that in 2004?
Provide a short and direct response. 0.95. What is the ratio of the Value added (current Local Currency Unit) of Chile in 2002 to that in 2005?
Provide a succinct answer. 0.87. What is the ratio of the Value added (current Local Currency Unit) in Lesotho in 2002 to that in 2005?
Your answer should be very brief. 0.9. What is the ratio of the Value added (current Local Currency Unit) in Lithuania in 2002 to that in 2005?
Offer a terse response. 0.8. What is the ratio of the Value added (current Local Currency Unit) in Chile in 2002 to that in 2006?
Your response must be concise. 0.87. What is the ratio of the Value added (current Local Currency Unit) of Lesotho in 2002 to that in 2006?
Your response must be concise. 0.92. What is the ratio of the Value added (current Local Currency Unit) of Lithuania in 2002 to that in 2006?
Your answer should be very brief. 0.78. What is the ratio of the Value added (current Local Currency Unit) of Chile in 2003 to that in 2004?
Provide a succinct answer. 0.98. What is the ratio of the Value added (current Local Currency Unit) in Lesotho in 2003 to that in 2004?
Offer a terse response. 0.96. What is the ratio of the Value added (current Local Currency Unit) of Lithuania in 2003 to that in 2004?
Offer a very short reply. 0.97. What is the ratio of the Value added (current Local Currency Unit) in Chile in 2003 to that in 2005?
Provide a succinct answer. 0.89. What is the ratio of the Value added (current Local Currency Unit) in Lesotho in 2003 to that in 2005?
Make the answer very short. 0.93. What is the ratio of the Value added (current Local Currency Unit) in Lithuania in 2003 to that in 2005?
Make the answer very short. 0.81. What is the ratio of the Value added (current Local Currency Unit) of Chile in 2003 to that in 2006?
Offer a terse response. 0.89. What is the ratio of the Value added (current Local Currency Unit) of Lesotho in 2003 to that in 2006?
Your answer should be compact. 0.95. What is the ratio of the Value added (current Local Currency Unit) in Lithuania in 2003 to that in 2006?
Your response must be concise. 0.79. What is the ratio of the Value added (current Local Currency Unit) in Chile in 2004 to that in 2005?
Provide a succinct answer. 0.91. What is the ratio of the Value added (current Local Currency Unit) of Lesotho in 2004 to that in 2005?
Provide a short and direct response. 0.97. What is the ratio of the Value added (current Local Currency Unit) of Lithuania in 2004 to that in 2005?
Ensure brevity in your answer.  0.84. What is the ratio of the Value added (current Local Currency Unit) in Chile in 2004 to that in 2006?
Offer a very short reply. 0.91. What is the ratio of the Value added (current Local Currency Unit) of Lesotho in 2004 to that in 2006?
Ensure brevity in your answer.  0.99. What is the ratio of the Value added (current Local Currency Unit) of Lithuania in 2004 to that in 2006?
Offer a terse response. 0.82. What is the ratio of the Value added (current Local Currency Unit) in Lesotho in 2005 to that in 2006?
Your response must be concise. 1.02. What is the ratio of the Value added (current Local Currency Unit) of Lithuania in 2005 to that in 2006?
Make the answer very short. 0.98. What is the difference between the highest and the second highest Value added (current Local Currency Unit) in Chile?
Ensure brevity in your answer.  6.26e+09. What is the difference between the highest and the second highest Value added (current Local Currency Unit) in Lesotho?
Your answer should be very brief. 1.01e+08. What is the difference between the highest and the second highest Value added (current Local Currency Unit) of Lithuania?
Your answer should be very brief. 2.14e+07. What is the difference between the highest and the lowest Value added (current Local Currency Unit) in Chile?
Offer a terse response. 8.42e+11. What is the difference between the highest and the lowest Value added (current Local Currency Unit) in Lesotho?
Provide a succinct answer. 2.34e+08. What is the difference between the highest and the lowest Value added (current Local Currency Unit) of Lithuania?
Provide a succinct answer. 2.38e+08. 